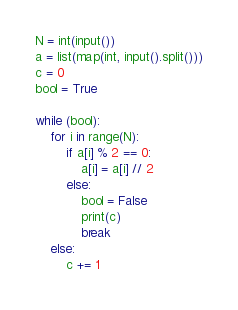Convert code to text. <code><loc_0><loc_0><loc_500><loc_500><_Python_>N = int(input())
a = list(map(int, input().split()))
c = 0
bool = True

while (bool):
    for i in range(N):
        if a[i] % 2 == 0:
            a[i] = a[i] // 2
        else:
            bool = False
            print(c)
            break    
    else:
        c += 1</code> 